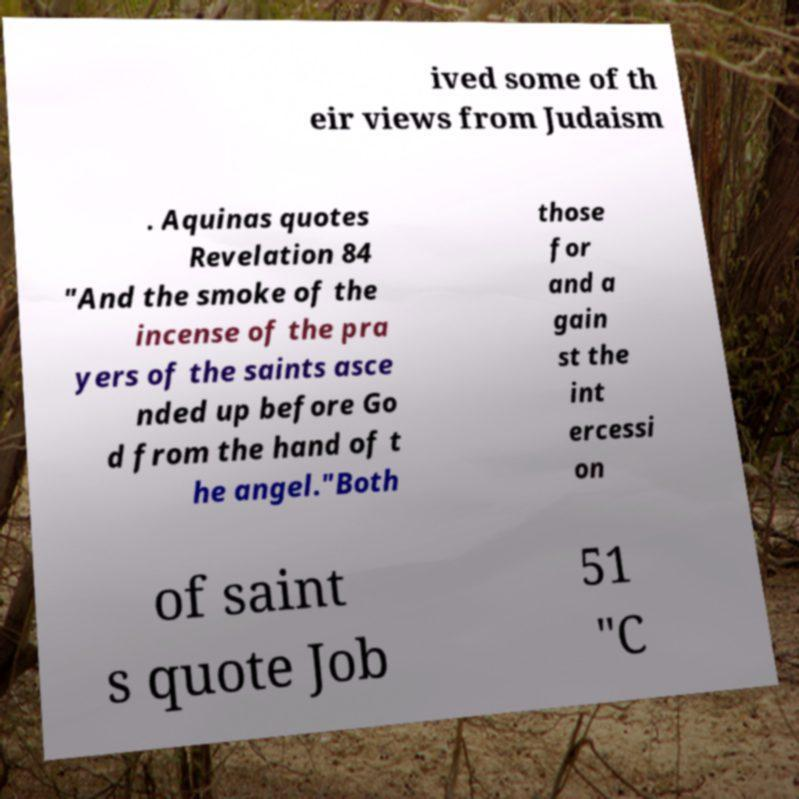Please read and relay the text visible in this image. What does it say? ived some of th eir views from Judaism . Aquinas quotes Revelation 84 "And the smoke of the incense of the pra yers of the saints asce nded up before Go d from the hand of t he angel."Both those for and a gain st the int ercessi on of saint s quote Job 51 "C 